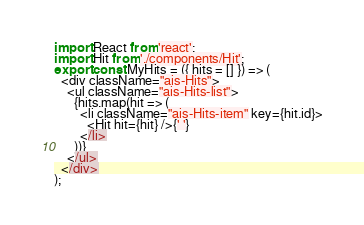<code> <loc_0><loc_0><loc_500><loc_500><_JavaScript_>import React from 'react';
import Hit from './components/Hit';
export const MyHits = ({ hits = [] }) => (
  <div className="ais-Hits">
    <ul className="ais-Hits-list">
      {hits.map(hit => (
        <li className="ais-Hits-item" key={hit.id}>
          <Hit hit={hit} />{' '}
        </li>
      ))}
    </ul>
  </div>
);
</code> 